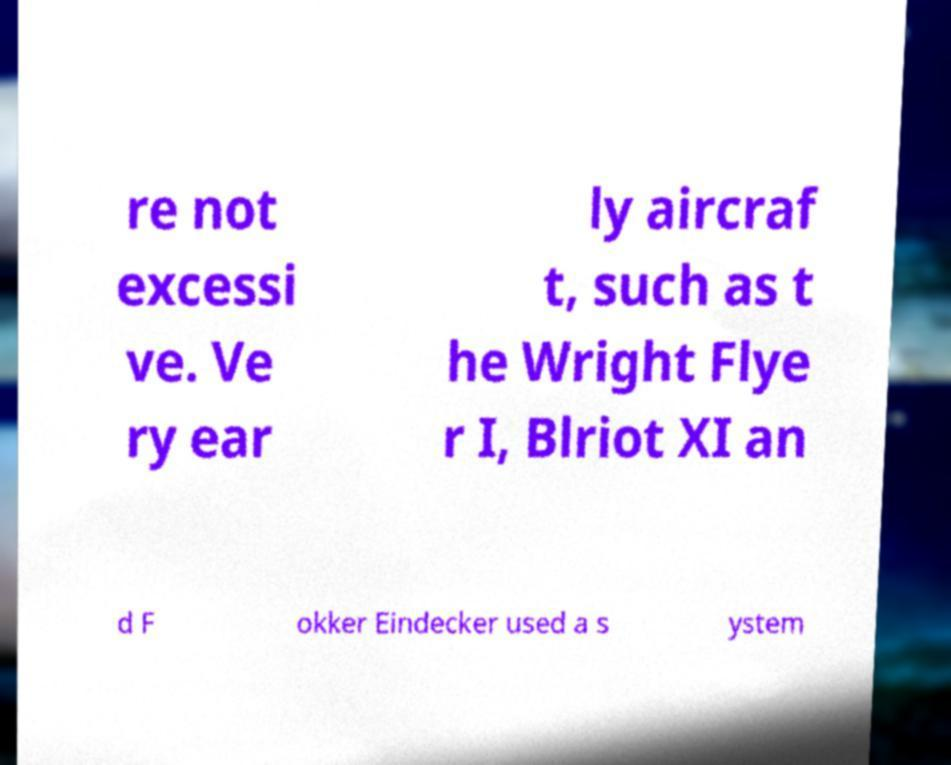Can you accurately transcribe the text from the provided image for me? re not excessi ve. Ve ry ear ly aircraf t, such as t he Wright Flye r I, Blriot XI an d F okker Eindecker used a s ystem 